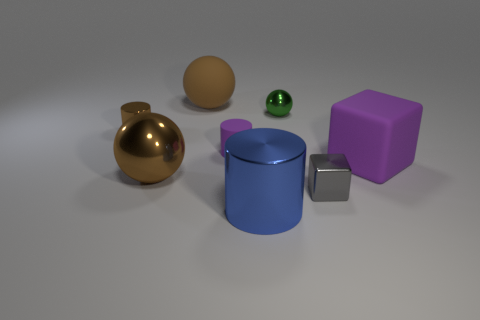What number of other objects are there of the same shape as the large purple thing?
Provide a succinct answer. 1. Is there a small green ball made of the same material as the purple cylinder?
Your answer should be compact. No. There is a purple object that is the same size as the brown cylinder; what is its material?
Keep it short and to the point. Rubber. There is a tiny cylinder in front of the object left of the brown shiny object in front of the large rubber cube; what color is it?
Offer a very short reply. Purple. Does the large metal thing that is left of the big blue metal thing have the same shape as the tiny metallic thing to the left of the large brown rubber ball?
Ensure brevity in your answer.  No. What number of blue metallic things are there?
Offer a terse response. 1. There is a shiny cylinder that is the same size as the gray shiny thing; what color is it?
Offer a terse response. Brown. Are the big object to the right of the big metallic cylinder and the brown object that is behind the tiny brown shiny cylinder made of the same material?
Ensure brevity in your answer.  Yes. What is the size of the sphere on the left side of the big sphere that is behind the big purple object?
Make the answer very short. Large. What is the material of the ball that is right of the large blue object?
Make the answer very short. Metal. 